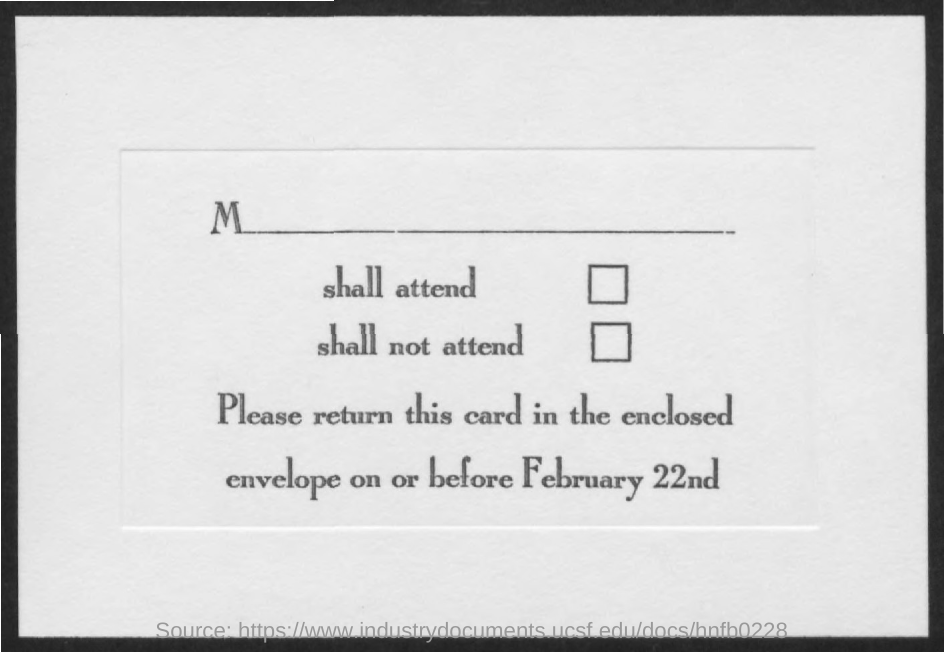When should the card be returned?
Your response must be concise. Before february 22nd. 